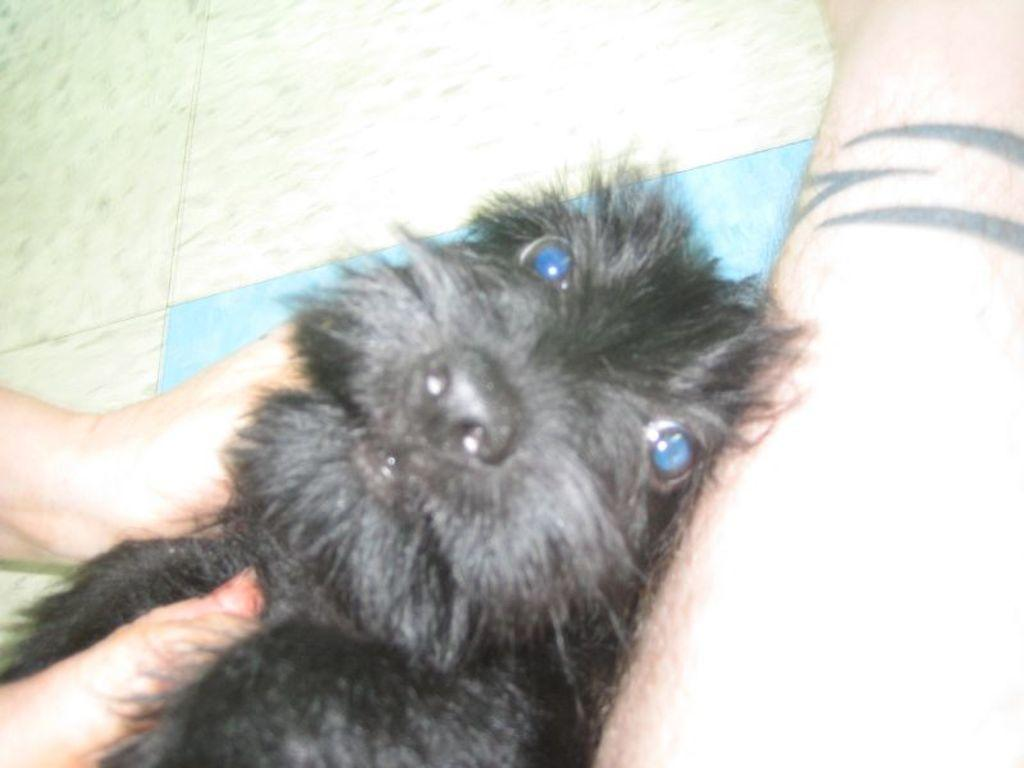What body parts can be seen in the image? Hands and a leg are visible in the image. What animal is present on the floor in the image? There is a dog on the floor in the image. What type of pear is being held by the plantation worker in the image? There is no pear or plantation worker present in the image. Can you describe the dog's tongue in the image? The image does not show the dog's tongue, so it cannot be described. 